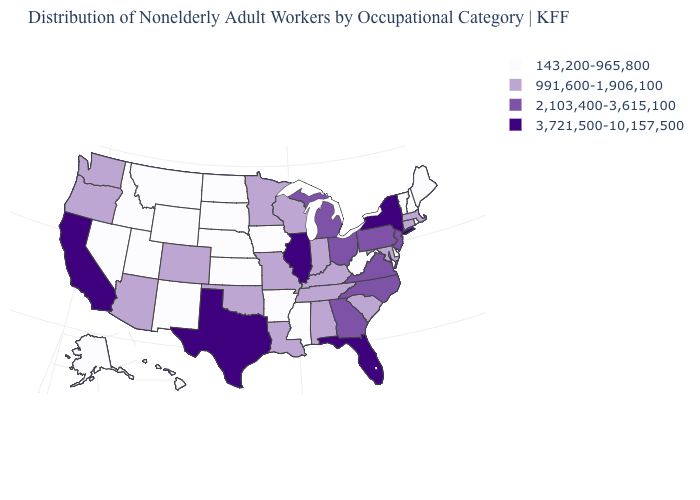Name the states that have a value in the range 143,200-965,800?
Keep it brief. Alaska, Arkansas, Delaware, Hawaii, Idaho, Iowa, Kansas, Maine, Mississippi, Montana, Nebraska, Nevada, New Hampshire, New Mexico, North Dakota, Rhode Island, South Dakota, Utah, Vermont, West Virginia, Wyoming. What is the value of Virginia?
Concise answer only. 2,103,400-3,615,100. Name the states that have a value in the range 991,600-1,906,100?
Concise answer only. Alabama, Arizona, Colorado, Connecticut, Indiana, Kentucky, Louisiana, Maryland, Massachusetts, Minnesota, Missouri, Oklahoma, Oregon, South Carolina, Tennessee, Washington, Wisconsin. Does California have the highest value in the West?
Write a very short answer. Yes. Among the states that border Idaho , which have the lowest value?
Quick response, please. Montana, Nevada, Utah, Wyoming. Among the states that border Wyoming , which have the lowest value?
Short answer required. Idaho, Montana, Nebraska, South Dakota, Utah. Among the states that border New York , does New Jersey have the highest value?
Give a very brief answer. Yes. How many symbols are there in the legend?
Concise answer only. 4. What is the highest value in states that border Rhode Island?
Concise answer only. 991,600-1,906,100. Does the map have missing data?
Write a very short answer. No. What is the highest value in states that border New Jersey?
Write a very short answer. 3,721,500-10,157,500. Name the states that have a value in the range 143,200-965,800?
Write a very short answer. Alaska, Arkansas, Delaware, Hawaii, Idaho, Iowa, Kansas, Maine, Mississippi, Montana, Nebraska, Nevada, New Hampshire, New Mexico, North Dakota, Rhode Island, South Dakota, Utah, Vermont, West Virginia, Wyoming. Does Ohio have the lowest value in the USA?
Quick response, please. No. What is the highest value in states that border Delaware?
Answer briefly. 2,103,400-3,615,100. What is the highest value in states that border Florida?
Give a very brief answer. 2,103,400-3,615,100. 